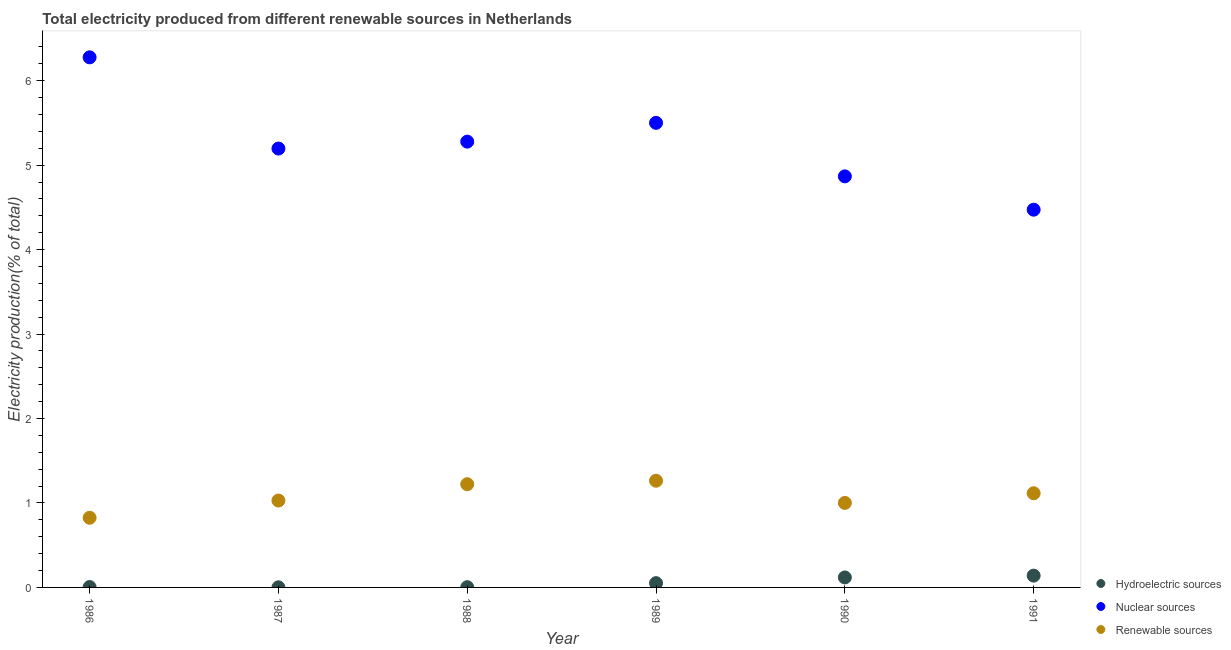Is the number of dotlines equal to the number of legend labels?
Offer a terse response. Yes. What is the percentage of electricity produced by nuclear sources in 1990?
Your answer should be compact. 4.87. Across all years, what is the maximum percentage of electricity produced by renewable sources?
Ensure brevity in your answer.  1.26. Across all years, what is the minimum percentage of electricity produced by renewable sources?
Offer a very short reply. 0.82. In which year was the percentage of electricity produced by nuclear sources maximum?
Your answer should be very brief. 1986. In which year was the percentage of electricity produced by nuclear sources minimum?
Your answer should be compact. 1991. What is the total percentage of electricity produced by renewable sources in the graph?
Make the answer very short. 6.46. What is the difference between the percentage of electricity produced by hydroelectric sources in 1987 and that in 1989?
Your response must be concise. -0.05. What is the difference between the percentage of electricity produced by nuclear sources in 1990 and the percentage of electricity produced by hydroelectric sources in 1986?
Your answer should be very brief. 4.86. What is the average percentage of electricity produced by renewable sources per year?
Provide a succinct answer. 1.08. In the year 1988, what is the difference between the percentage of electricity produced by hydroelectric sources and percentage of electricity produced by renewable sources?
Ensure brevity in your answer.  -1.22. What is the ratio of the percentage of electricity produced by hydroelectric sources in 1988 to that in 1991?
Keep it short and to the point. 0.02. What is the difference between the highest and the second highest percentage of electricity produced by nuclear sources?
Keep it short and to the point. 0.78. What is the difference between the highest and the lowest percentage of electricity produced by renewable sources?
Make the answer very short. 0.44. Is the sum of the percentage of electricity produced by hydroelectric sources in 1988 and 1991 greater than the maximum percentage of electricity produced by nuclear sources across all years?
Offer a very short reply. No. Is it the case that in every year, the sum of the percentage of electricity produced by hydroelectric sources and percentage of electricity produced by nuclear sources is greater than the percentage of electricity produced by renewable sources?
Keep it short and to the point. Yes. Does the percentage of electricity produced by hydroelectric sources monotonically increase over the years?
Give a very brief answer. No. Is the percentage of electricity produced by renewable sources strictly less than the percentage of electricity produced by nuclear sources over the years?
Make the answer very short. Yes. What is the difference between two consecutive major ticks on the Y-axis?
Provide a short and direct response. 1. Does the graph contain grids?
Ensure brevity in your answer.  No. How many legend labels are there?
Your answer should be compact. 3. What is the title of the graph?
Your answer should be very brief. Total electricity produced from different renewable sources in Netherlands. What is the label or title of the X-axis?
Give a very brief answer. Year. What is the Electricity production(% of total) of Hydroelectric sources in 1986?
Your answer should be compact. 0. What is the Electricity production(% of total) of Nuclear sources in 1986?
Ensure brevity in your answer.  6.28. What is the Electricity production(% of total) of Renewable sources in 1986?
Provide a short and direct response. 0.82. What is the Electricity production(% of total) of Hydroelectric sources in 1987?
Keep it short and to the point. 0. What is the Electricity production(% of total) in Nuclear sources in 1987?
Offer a terse response. 5.2. What is the Electricity production(% of total) of Renewable sources in 1987?
Your answer should be very brief. 1.03. What is the Electricity production(% of total) in Hydroelectric sources in 1988?
Your response must be concise. 0. What is the Electricity production(% of total) in Nuclear sources in 1988?
Offer a very short reply. 5.28. What is the Electricity production(% of total) of Renewable sources in 1988?
Provide a short and direct response. 1.22. What is the Electricity production(% of total) in Hydroelectric sources in 1989?
Offer a very short reply. 0.05. What is the Electricity production(% of total) of Nuclear sources in 1989?
Make the answer very short. 5.5. What is the Electricity production(% of total) of Renewable sources in 1989?
Your response must be concise. 1.26. What is the Electricity production(% of total) of Hydroelectric sources in 1990?
Make the answer very short. 0.12. What is the Electricity production(% of total) in Nuclear sources in 1990?
Your answer should be compact. 4.87. What is the Electricity production(% of total) in Renewable sources in 1990?
Provide a succinct answer. 1. What is the Electricity production(% of total) in Hydroelectric sources in 1991?
Offer a terse response. 0.14. What is the Electricity production(% of total) in Nuclear sources in 1991?
Provide a succinct answer. 4.47. What is the Electricity production(% of total) in Renewable sources in 1991?
Provide a short and direct response. 1.12. Across all years, what is the maximum Electricity production(% of total) of Hydroelectric sources?
Ensure brevity in your answer.  0.14. Across all years, what is the maximum Electricity production(% of total) of Nuclear sources?
Provide a succinct answer. 6.28. Across all years, what is the maximum Electricity production(% of total) of Renewable sources?
Provide a succinct answer. 1.26. Across all years, what is the minimum Electricity production(% of total) of Hydroelectric sources?
Keep it short and to the point. 0. Across all years, what is the minimum Electricity production(% of total) of Nuclear sources?
Give a very brief answer. 4.47. Across all years, what is the minimum Electricity production(% of total) in Renewable sources?
Provide a short and direct response. 0.82. What is the total Electricity production(% of total) of Hydroelectric sources in the graph?
Offer a terse response. 0.32. What is the total Electricity production(% of total) of Nuclear sources in the graph?
Keep it short and to the point. 31.6. What is the total Electricity production(% of total) in Renewable sources in the graph?
Your response must be concise. 6.46. What is the difference between the Electricity production(% of total) of Hydroelectric sources in 1986 and that in 1987?
Make the answer very short. 0. What is the difference between the Electricity production(% of total) in Nuclear sources in 1986 and that in 1987?
Provide a short and direct response. 1.08. What is the difference between the Electricity production(% of total) in Renewable sources in 1986 and that in 1987?
Provide a short and direct response. -0.2. What is the difference between the Electricity production(% of total) in Hydroelectric sources in 1986 and that in 1988?
Provide a succinct answer. 0. What is the difference between the Electricity production(% of total) of Renewable sources in 1986 and that in 1988?
Give a very brief answer. -0.4. What is the difference between the Electricity production(% of total) in Hydroelectric sources in 1986 and that in 1989?
Your answer should be compact. -0.05. What is the difference between the Electricity production(% of total) in Nuclear sources in 1986 and that in 1989?
Your response must be concise. 0.78. What is the difference between the Electricity production(% of total) in Renewable sources in 1986 and that in 1989?
Offer a very short reply. -0.44. What is the difference between the Electricity production(% of total) in Hydroelectric sources in 1986 and that in 1990?
Offer a terse response. -0.11. What is the difference between the Electricity production(% of total) of Nuclear sources in 1986 and that in 1990?
Give a very brief answer. 1.41. What is the difference between the Electricity production(% of total) of Renewable sources in 1986 and that in 1990?
Make the answer very short. -0.18. What is the difference between the Electricity production(% of total) of Hydroelectric sources in 1986 and that in 1991?
Make the answer very short. -0.14. What is the difference between the Electricity production(% of total) of Nuclear sources in 1986 and that in 1991?
Provide a succinct answer. 1.8. What is the difference between the Electricity production(% of total) in Renewable sources in 1986 and that in 1991?
Give a very brief answer. -0.29. What is the difference between the Electricity production(% of total) in Hydroelectric sources in 1987 and that in 1988?
Keep it short and to the point. -0. What is the difference between the Electricity production(% of total) of Nuclear sources in 1987 and that in 1988?
Provide a succinct answer. -0.08. What is the difference between the Electricity production(% of total) in Renewable sources in 1987 and that in 1988?
Give a very brief answer. -0.19. What is the difference between the Electricity production(% of total) of Hydroelectric sources in 1987 and that in 1989?
Give a very brief answer. -0.05. What is the difference between the Electricity production(% of total) of Nuclear sources in 1987 and that in 1989?
Your answer should be compact. -0.3. What is the difference between the Electricity production(% of total) of Renewable sources in 1987 and that in 1989?
Offer a very short reply. -0.23. What is the difference between the Electricity production(% of total) in Hydroelectric sources in 1987 and that in 1990?
Offer a terse response. -0.12. What is the difference between the Electricity production(% of total) of Nuclear sources in 1987 and that in 1990?
Provide a succinct answer. 0.33. What is the difference between the Electricity production(% of total) of Renewable sources in 1987 and that in 1990?
Provide a succinct answer. 0.03. What is the difference between the Electricity production(% of total) of Hydroelectric sources in 1987 and that in 1991?
Your response must be concise. -0.14. What is the difference between the Electricity production(% of total) of Nuclear sources in 1987 and that in 1991?
Provide a succinct answer. 0.72. What is the difference between the Electricity production(% of total) of Renewable sources in 1987 and that in 1991?
Provide a short and direct response. -0.09. What is the difference between the Electricity production(% of total) of Hydroelectric sources in 1988 and that in 1989?
Your response must be concise. -0.05. What is the difference between the Electricity production(% of total) of Nuclear sources in 1988 and that in 1989?
Provide a short and direct response. -0.22. What is the difference between the Electricity production(% of total) in Renewable sources in 1988 and that in 1989?
Offer a terse response. -0.04. What is the difference between the Electricity production(% of total) in Hydroelectric sources in 1988 and that in 1990?
Give a very brief answer. -0.12. What is the difference between the Electricity production(% of total) in Nuclear sources in 1988 and that in 1990?
Offer a terse response. 0.41. What is the difference between the Electricity production(% of total) in Renewable sources in 1988 and that in 1990?
Make the answer very short. 0.22. What is the difference between the Electricity production(% of total) of Hydroelectric sources in 1988 and that in 1991?
Ensure brevity in your answer.  -0.14. What is the difference between the Electricity production(% of total) of Nuclear sources in 1988 and that in 1991?
Provide a succinct answer. 0.81. What is the difference between the Electricity production(% of total) of Renewable sources in 1988 and that in 1991?
Your response must be concise. 0.11. What is the difference between the Electricity production(% of total) in Hydroelectric sources in 1989 and that in 1990?
Your answer should be compact. -0.07. What is the difference between the Electricity production(% of total) of Nuclear sources in 1989 and that in 1990?
Your answer should be compact. 0.63. What is the difference between the Electricity production(% of total) of Renewable sources in 1989 and that in 1990?
Your answer should be compact. 0.26. What is the difference between the Electricity production(% of total) of Hydroelectric sources in 1989 and that in 1991?
Your response must be concise. -0.09. What is the difference between the Electricity production(% of total) of Nuclear sources in 1989 and that in 1991?
Offer a very short reply. 1.03. What is the difference between the Electricity production(% of total) of Renewable sources in 1989 and that in 1991?
Offer a terse response. 0.15. What is the difference between the Electricity production(% of total) of Hydroelectric sources in 1990 and that in 1991?
Offer a very short reply. -0.02. What is the difference between the Electricity production(% of total) of Nuclear sources in 1990 and that in 1991?
Your answer should be very brief. 0.39. What is the difference between the Electricity production(% of total) in Renewable sources in 1990 and that in 1991?
Give a very brief answer. -0.11. What is the difference between the Electricity production(% of total) in Hydroelectric sources in 1986 and the Electricity production(% of total) in Nuclear sources in 1987?
Provide a succinct answer. -5.19. What is the difference between the Electricity production(% of total) in Hydroelectric sources in 1986 and the Electricity production(% of total) in Renewable sources in 1987?
Keep it short and to the point. -1.02. What is the difference between the Electricity production(% of total) in Nuclear sources in 1986 and the Electricity production(% of total) in Renewable sources in 1987?
Provide a short and direct response. 5.25. What is the difference between the Electricity production(% of total) in Hydroelectric sources in 1986 and the Electricity production(% of total) in Nuclear sources in 1988?
Provide a short and direct response. -5.27. What is the difference between the Electricity production(% of total) of Hydroelectric sources in 1986 and the Electricity production(% of total) of Renewable sources in 1988?
Give a very brief answer. -1.22. What is the difference between the Electricity production(% of total) of Nuclear sources in 1986 and the Electricity production(% of total) of Renewable sources in 1988?
Provide a succinct answer. 5.06. What is the difference between the Electricity production(% of total) of Hydroelectric sources in 1986 and the Electricity production(% of total) of Nuclear sources in 1989?
Make the answer very short. -5.5. What is the difference between the Electricity production(% of total) of Hydroelectric sources in 1986 and the Electricity production(% of total) of Renewable sources in 1989?
Offer a terse response. -1.26. What is the difference between the Electricity production(% of total) of Nuclear sources in 1986 and the Electricity production(% of total) of Renewable sources in 1989?
Give a very brief answer. 5.01. What is the difference between the Electricity production(% of total) in Hydroelectric sources in 1986 and the Electricity production(% of total) in Nuclear sources in 1990?
Ensure brevity in your answer.  -4.86. What is the difference between the Electricity production(% of total) of Hydroelectric sources in 1986 and the Electricity production(% of total) of Renewable sources in 1990?
Make the answer very short. -1. What is the difference between the Electricity production(% of total) of Nuclear sources in 1986 and the Electricity production(% of total) of Renewable sources in 1990?
Provide a succinct answer. 5.28. What is the difference between the Electricity production(% of total) of Hydroelectric sources in 1986 and the Electricity production(% of total) of Nuclear sources in 1991?
Give a very brief answer. -4.47. What is the difference between the Electricity production(% of total) in Hydroelectric sources in 1986 and the Electricity production(% of total) in Renewable sources in 1991?
Provide a succinct answer. -1.11. What is the difference between the Electricity production(% of total) of Nuclear sources in 1986 and the Electricity production(% of total) of Renewable sources in 1991?
Keep it short and to the point. 5.16. What is the difference between the Electricity production(% of total) in Hydroelectric sources in 1987 and the Electricity production(% of total) in Nuclear sources in 1988?
Your answer should be very brief. -5.28. What is the difference between the Electricity production(% of total) in Hydroelectric sources in 1987 and the Electricity production(% of total) in Renewable sources in 1988?
Your response must be concise. -1.22. What is the difference between the Electricity production(% of total) of Nuclear sources in 1987 and the Electricity production(% of total) of Renewable sources in 1988?
Your answer should be very brief. 3.97. What is the difference between the Electricity production(% of total) of Hydroelectric sources in 1987 and the Electricity production(% of total) of Nuclear sources in 1989?
Give a very brief answer. -5.5. What is the difference between the Electricity production(% of total) in Hydroelectric sources in 1987 and the Electricity production(% of total) in Renewable sources in 1989?
Make the answer very short. -1.26. What is the difference between the Electricity production(% of total) of Nuclear sources in 1987 and the Electricity production(% of total) of Renewable sources in 1989?
Your response must be concise. 3.93. What is the difference between the Electricity production(% of total) in Hydroelectric sources in 1987 and the Electricity production(% of total) in Nuclear sources in 1990?
Give a very brief answer. -4.87. What is the difference between the Electricity production(% of total) of Hydroelectric sources in 1987 and the Electricity production(% of total) of Renewable sources in 1990?
Ensure brevity in your answer.  -1. What is the difference between the Electricity production(% of total) in Nuclear sources in 1987 and the Electricity production(% of total) in Renewable sources in 1990?
Keep it short and to the point. 4.2. What is the difference between the Electricity production(% of total) in Hydroelectric sources in 1987 and the Electricity production(% of total) in Nuclear sources in 1991?
Provide a succinct answer. -4.47. What is the difference between the Electricity production(% of total) of Hydroelectric sources in 1987 and the Electricity production(% of total) of Renewable sources in 1991?
Offer a very short reply. -1.11. What is the difference between the Electricity production(% of total) of Nuclear sources in 1987 and the Electricity production(% of total) of Renewable sources in 1991?
Ensure brevity in your answer.  4.08. What is the difference between the Electricity production(% of total) of Hydroelectric sources in 1988 and the Electricity production(% of total) of Nuclear sources in 1989?
Make the answer very short. -5.5. What is the difference between the Electricity production(% of total) in Hydroelectric sources in 1988 and the Electricity production(% of total) in Renewable sources in 1989?
Your answer should be compact. -1.26. What is the difference between the Electricity production(% of total) in Nuclear sources in 1988 and the Electricity production(% of total) in Renewable sources in 1989?
Keep it short and to the point. 4.02. What is the difference between the Electricity production(% of total) in Hydroelectric sources in 1988 and the Electricity production(% of total) in Nuclear sources in 1990?
Ensure brevity in your answer.  -4.87. What is the difference between the Electricity production(% of total) of Hydroelectric sources in 1988 and the Electricity production(% of total) of Renewable sources in 1990?
Keep it short and to the point. -1. What is the difference between the Electricity production(% of total) of Nuclear sources in 1988 and the Electricity production(% of total) of Renewable sources in 1990?
Make the answer very short. 4.28. What is the difference between the Electricity production(% of total) of Hydroelectric sources in 1988 and the Electricity production(% of total) of Nuclear sources in 1991?
Provide a succinct answer. -4.47. What is the difference between the Electricity production(% of total) of Hydroelectric sources in 1988 and the Electricity production(% of total) of Renewable sources in 1991?
Offer a very short reply. -1.11. What is the difference between the Electricity production(% of total) in Nuclear sources in 1988 and the Electricity production(% of total) in Renewable sources in 1991?
Give a very brief answer. 4.16. What is the difference between the Electricity production(% of total) in Hydroelectric sources in 1989 and the Electricity production(% of total) in Nuclear sources in 1990?
Provide a short and direct response. -4.82. What is the difference between the Electricity production(% of total) in Hydroelectric sources in 1989 and the Electricity production(% of total) in Renewable sources in 1990?
Keep it short and to the point. -0.95. What is the difference between the Electricity production(% of total) of Nuclear sources in 1989 and the Electricity production(% of total) of Renewable sources in 1990?
Your answer should be very brief. 4.5. What is the difference between the Electricity production(% of total) of Hydroelectric sources in 1989 and the Electricity production(% of total) of Nuclear sources in 1991?
Your answer should be compact. -4.42. What is the difference between the Electricity production(% of total) in Hydroelectric sources in 1989 and the Electricity production(% of total) in Renewable sources in 1991?
Offer a very short reply. -1.06. What is the difference between the Electricity production(% of total) in Nuclear sources in 1989 and the Electricity production(% of total) in Renewable sources in 1991?
Give a very brief answer. 4.39. What is the difference between the Electricity production(% of total) of Hydroelectric sources in 1990 and the Electricity production(% of total) of Nuclear sources in 1991?
Provide a short and direct response. -4.36. What is the difference between the Electricity production(% of total) of Hydroelectric sources in 1990 and the Electricity production(% of total) of Renewable sources in 1991?
Provide a succinct answer. -1. What is the difference between the Electricity production(% of total) of Nuclear sources in 1990 and the Electricity production(% of total) of Renewable sources in 1991?
Offer a very short reply. 3.75. What is the average Electricity production(% of total) in Hydroelectric sources per year?
Provide a short and direct response. 0.05. What is the average Electricity production(% of total) in Nuclear sources per year?
Give a very brief answer. 5.27. What is the average Electricity production(% of total) of Renewable sources per year?
Keep it short and to the point. 1.08. In the year 1986, what is the difference between the Electricity production(% of total) of Hydroelectric sources and Electricity production(% of total) of Nuclear sources?
Give a very brief answer. -6.27. In the year 1986, what is the difference between the Electricity production(% of total) in Hydroelectric sources and Electricity production(% of total) in Renewable sources?
Provide a short and direct response. -0.82. In the year 1986, what is the difference between the Electricity production(% of total) in Nuclear sources and Electricity production(% of total) in Renewable sources?
Your response must be concise. 5.45. In the year 1987, what is the difference between the Electricity production(% of total) in Hydroelectric sources and Electricity production(% of total) in Nuclear sources?
Offer a very short reply. -5.2. In the year 1987, what is the difference between the Electricity production(% of total) in Hydroelectric sources and Electricity production(% of total) in Renewable sources?
Offer a very short reply. -1.03. In the year 1987, what is the difference between the Electricity production(% of total) in Nuclear sources and Electricity production(% of total) in Renewable sources?
Your response must be concise. 4.17. In the year 1988, what is the difference between the Electricity production(% of total) in Hydroelectric sources and Electricity production(% of total) in Nuclear sources?
Your response must be concise. -5.28. In the year 1988, what is the difference between the Electricity production(% of total) of Hydroelectric sources and Electricity production(% of total) of Renewable sources?
Your response must be concise. -1.22. In the year 1988, what is the difference between the Electricity production(% of total) in Nuclear sources and Electricity production(% of total) in Renewable sources?
Your answer should be very brief. 4.06. In the year 1989, what is the difference between the Electricity production(% of total) of Hydroelectric sources and Electricity production(% of total) of Nuclear sources?
Your response must be concise. -5.45. In the year 1989, what is the difference between the Electricity production(% of total) in Hydroelectric sources and Electricity production(% of total) in Renewable sources?
Offer a terse response. -1.21. In the year 1989, what is the difference between the Electricity production(% of total) of Nuclear sources and Electricity production(% of total) of Renewable sources?
Keep it short and to the point. 4.24. In the year 1990, what is the difference between the Electricity production(% of total) in Hydroelectric sources and Electricity production(% of total) in Nuclear sources?
Make the answer very short. -4.75. In the year 1990, what is the difference between the Electricity production(% of total) of Hydroelectric sources and Electricity production(% of total) of Renewable sources?
Your response must be concise. -0.88. In the year 1990, what is the difference between the Electricity production(% of total) of Nuclear sources and Electricity production(% of total) of Renewable sources?
Offer a terse response. 3.87. In the year 1991, what is the difference between the Electricity production(% of total) in Hydroelectric sources and Electricity production(% of total) in Nuclear sources?
Your response must be concise. -4.33. In the year 1991, what is the difference between the Electricity production(% of total) in Hydroelectric sources and Electricity production(% of total) in Renewable sources?
Offer a very short reply. -0.98. In the year 1991, what is the difference between the Electricity production(% of total) in Nuclear sources and Electricity production(% of total) in Renewable sources?
Provide a short and direct response. 3.36. What is the ratio of the Electricity production(% of total) of Hydroelectric sources in 1986 to that in 1987?
Provide a short and direct response. 3.06. What is the ratio of the Electricity production(% of total) in Nuclear sources in 1986 to that in 1987?
Ensure brevity in your answer.  1.21. What is the ratio of the Electricity production(% of total) of Renewable sources in 1986 to that in 1987?
Your answer should be very brief. 0.8. What is the ratio of the Electricity production(% of total) of Hydroelectric sources in 1986 to that in 1988?
Keep it short and to the point. 1.55. What is the ratio of the Electricity production(% of total) of Nuclear sources in 1986 to that in 1988?
Offer a terse response. 1.19. What is the ratio of the Electricity production(% of total) of Renewable sources in 1986 to that in 1988?
Provide a succinct answer. 0.67. What is the ratio of the Electricity production(% of total) in Hydroelectric sources in 1986 to that in 1989?
Ensure brevity in your answer.  0.09. What is the ratio of the Electricity production(% of total) in Nuclear sources in 1986 to that in 1989?
Keep it short and to the point. 1.14. What is the ratio of the Electricity production(% of total) in Renewable sources in 1986 to that in 1989?
Give a very brief answer. 0.65. What is the ratio of the Electricity production(% of total) of Hydroelectric sources in 1986 to that in 1990?
Keep it short and to the point. 0.04. What is the ratio of the Electricity production(% of total) of Nuclear sources in 1986 to that in 1990?
Provide a short and direct response. 1.29. What is the ratio of the Electricity production(% of total) of Renewable sources in 1986 to that in 1990?
Offer a very short reply. 0.82. What is the ratio of the Electricity production(% of total) in Hydroelectric sources in 1986 to that in 1991?
Keep it short and to the point. 0.03. What is the ratio of the Electricity production(% of total) in Nuclear sources in 1986 to that in 1991?
Ensure brevity in your answer.  1.4. What is the ratio of the Electricity production(% of total) of Renewable sources in 1986 to that in 1991?
Ensure brevity in your answer.  0.74. What is the ratio of the Electricity production(% of total) in Hydroelectric sources in 1987 to that in 1988?
Ensure brevity in your answer.  0.51. What is the ratio of the Electricity production(% of total) in Nuclear sources in 1987 to that in 1988?
Make the answer very short. 0.98. What is the ratio of the Electricity production(% of total) of Renewable sources in 1987 to that in 1988?
Your answer should be compact. 0.84. What is the ratio of the Electricity production(% of total) of Hydroelectric sources in 1987 to that in 1989?
Ensure brevity in your answer.  0.03. What is the ratio of the Electricity production(% of total) of Nuclear sources in 1987 to that in 1989?
Keep it short and to the point. 0.94. What is the ratio of the Electricity production(% of total) in Renewable sources in 1987 to that in 1989?
Keep it short and to the point. 0.81. What is the ratio of the Electricity production(% of total) of Hydroelectric sources in 1987 to that in 1990?
Your answer should be very brief. 0.01. What is the ratio of the Electricity production(% of total) in Nuclear sources in 1987 to that in 1990?
Offer a terse response. 1.07. What is the ratio of the Electricity production(% of total) of Renewable sources in 1987 to that in 1990?
Make the answer very short. 1.03. What is the ratio of the Electricity production(% of total) of Hydroelectric sources in 1987 to that in 1991?
Make the answer very short. 0.01. What is the ratio of the Electricity production(% of total) in Nuclear sources in 1987 to that in 1991?
Offer a terse response. 1.16. What is the ratio of the Electricity production(% of total) in Renewable sources in 1987 to that in 1991?
Provide a succinct answer. 0.92. What is the ratio of the Electricity production(% of total) in Hydroelectric sources in 1988 to that in 1989?
Give a very brief answer. 0.06. What is the ratio of the Electricity production(% of total) in Nuclear sources in 1988 to that in 1989?
Offer a very short reply. 0.96. What is the ratio of the Electricity production(% of total) of Renewable sources in 1988 to that in 1989?
Ensure brevity in your answer.  0.97. What is the ratio of the Electricity production(% of total) in Hydroelectric sources in 1988 to that in 1990?
Offer a terse response. 0.02. What is the ratio of the Electricity production(% of total) in Nuclear sources in 1988 to that in 1990?
Provide a short and direct response. 1.08. What is the ratio of the Electricity production(% of total) of Renewable sources in 1988 to that in 1990?
Offer a terse response. 1.22. What is the ratio of the Electricity production(% of total) in Hydroelectric sources in 1988 to that in 1991?
Your answer should be very brief. 0.02. What is the ratio of the Electricity production(% of total) in Nuclear sources in 1988 to that in 1991?
Keep it short and to the point. 1.18. What is the ratio of the Electricity production(% of total) of Renewable sources in 1988 to that in 1991?
Give a very brief answer. 1.1. What is the ratio of the Electricity production(% of total) in Hydroelectric sources in 1989 to that in 1990?
Your answer should be very brief. 0.43. What is the ratio of the Electricity production(% of total) in Nuclear sources in 1989 to that in 1990?
Your response must be concise. 1.13. What is the ratio of the Electricity production(% of total) of Renewable sources in 1989 to that in 1990?
Offer a very short reply. 1.26. What is the ratio of the Electricity production(% of total) in Hydroelectric sources in 1989 to that in 1991?
Offer a terse response. 0.36. What is the ratio of the Electricity production(% of total) in Nuclear sources in 1989 to that in 1991?
Provide a succinct answer. 1.23. What is the ratio of the Electricity production(% of total) of Renewable sources in 1989 to that in 1991?
Give a very brief answer. 1.13. What is the ratio of the Electricity production(% of total) in Hydroelectric sources in 1990 to that in 1991?
Your answer should be compact. 0.85. What is the ratio of the Electricity production(% of total) in Nuclear sources in 1990 to that in 1991?
Your answer should be very brief. 1.09. What is the ratio of the Electricity production(% of total) in Renewable sources in 1990 to that in 1991?
Your response must be concise. 0.9. What is the difference between the highest and the second highest Electricity production(% of total) of Hydroelectric sources?
Ensure brevity in your answer.  0.02. What is the difference between the highest and the second highest Electricity production(% of total) of Nuclear sources?
Give a very brief answer. 0.78. What is the difference between the highest and the second highest Electricity production(% of total) in Renewable sources?
Offer a very short reply. 0.04. What is the difference between the highest and the lowest Electricity production(% of total) of Hydroelectric sources?
Provide a short and direct response. 0.14. What is the difference between the highest and the lowest Electricity production(% of total) of Nuclear sources?
Offer a terse response. 1.8. What is the difference between the highest and the lowest Electricity production(% of total) of Renewable sources?
Your answer should be very brief. 0.44. 